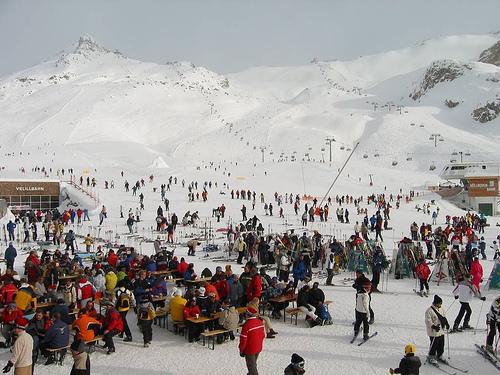Do you see anyone wearing skis?
Answer briefly. Yes. What are all these people standing on?
Write a very short answer. Snow. Is it summer?
Quick response, please. No. 